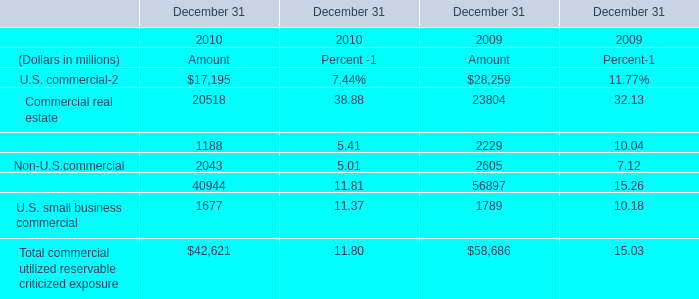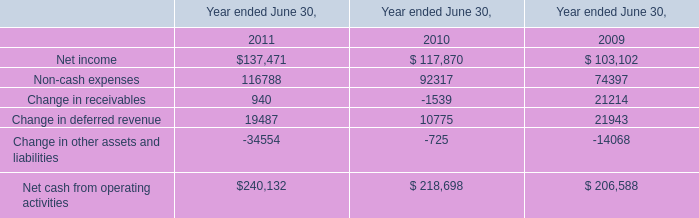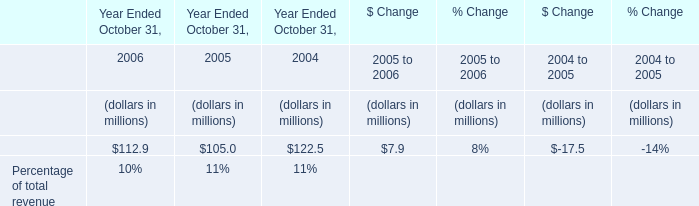What's the total amount of commercial utilized reservable criticized exposure excluding those commercial utilized reservable criticized exposure greater than 15000 in 2010? (in million) 
Computations: (17195 + 20518)
Answer: 37713.0. 